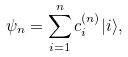<formula> <loc_0><loc_0><loc_500><loc_500>\psi _ { n } = \sum _ { i = 1 } ^ { n } c _ { i } ^ { ( n ) } | i \rangle ,</formula> 